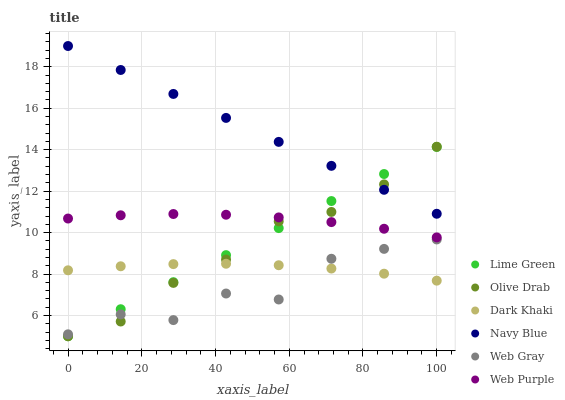Does Web Gray have the minimum area under the curve?
Answer yes or no. Yes. Does Navy Blue have the maximum area under the curve?
Answer yes or no. Yes. Does Dark Khaki have the minimum area under the curve?
Answer yes or no. No. Does Dark Khaki have the maximum area under the curve?
Answer yes or no. No. Is Lime Green the smoothest?
Answer yes or no. Yes. Is Web Gray the roughest?
Answer yes or no. Yes. Is Navy Blue the smoothest?
Answer yes or no. No. Is Navy Blue the roughest?
Answer yes or no. No. Does Lime Green have the lowest value?
Answer yes or no. Yes. Does Dark Khaki have the lowest value?
Answer yes or no. No. Does Navy Blue have the highest value?
Answer yes or no. Yes. Does Dark Khaki have the highest value?
Answer yes or no. No. Is Web Purple less than Navy Blue?
Answer yes or no. Yes. Is Navy Blue greater than Dark Khaki?
Answer yes or no. Yes. Does Web Purple intersect Lime Green?
Answer yes or no. Yes. Is Web Purple less than Lime Green?
Answer yes or no. No. Is Web Purple greater than Lime Green?
Answer yes or no. No. Does Web Purple intersect Navy Blue?
Answer yes or no. No. 